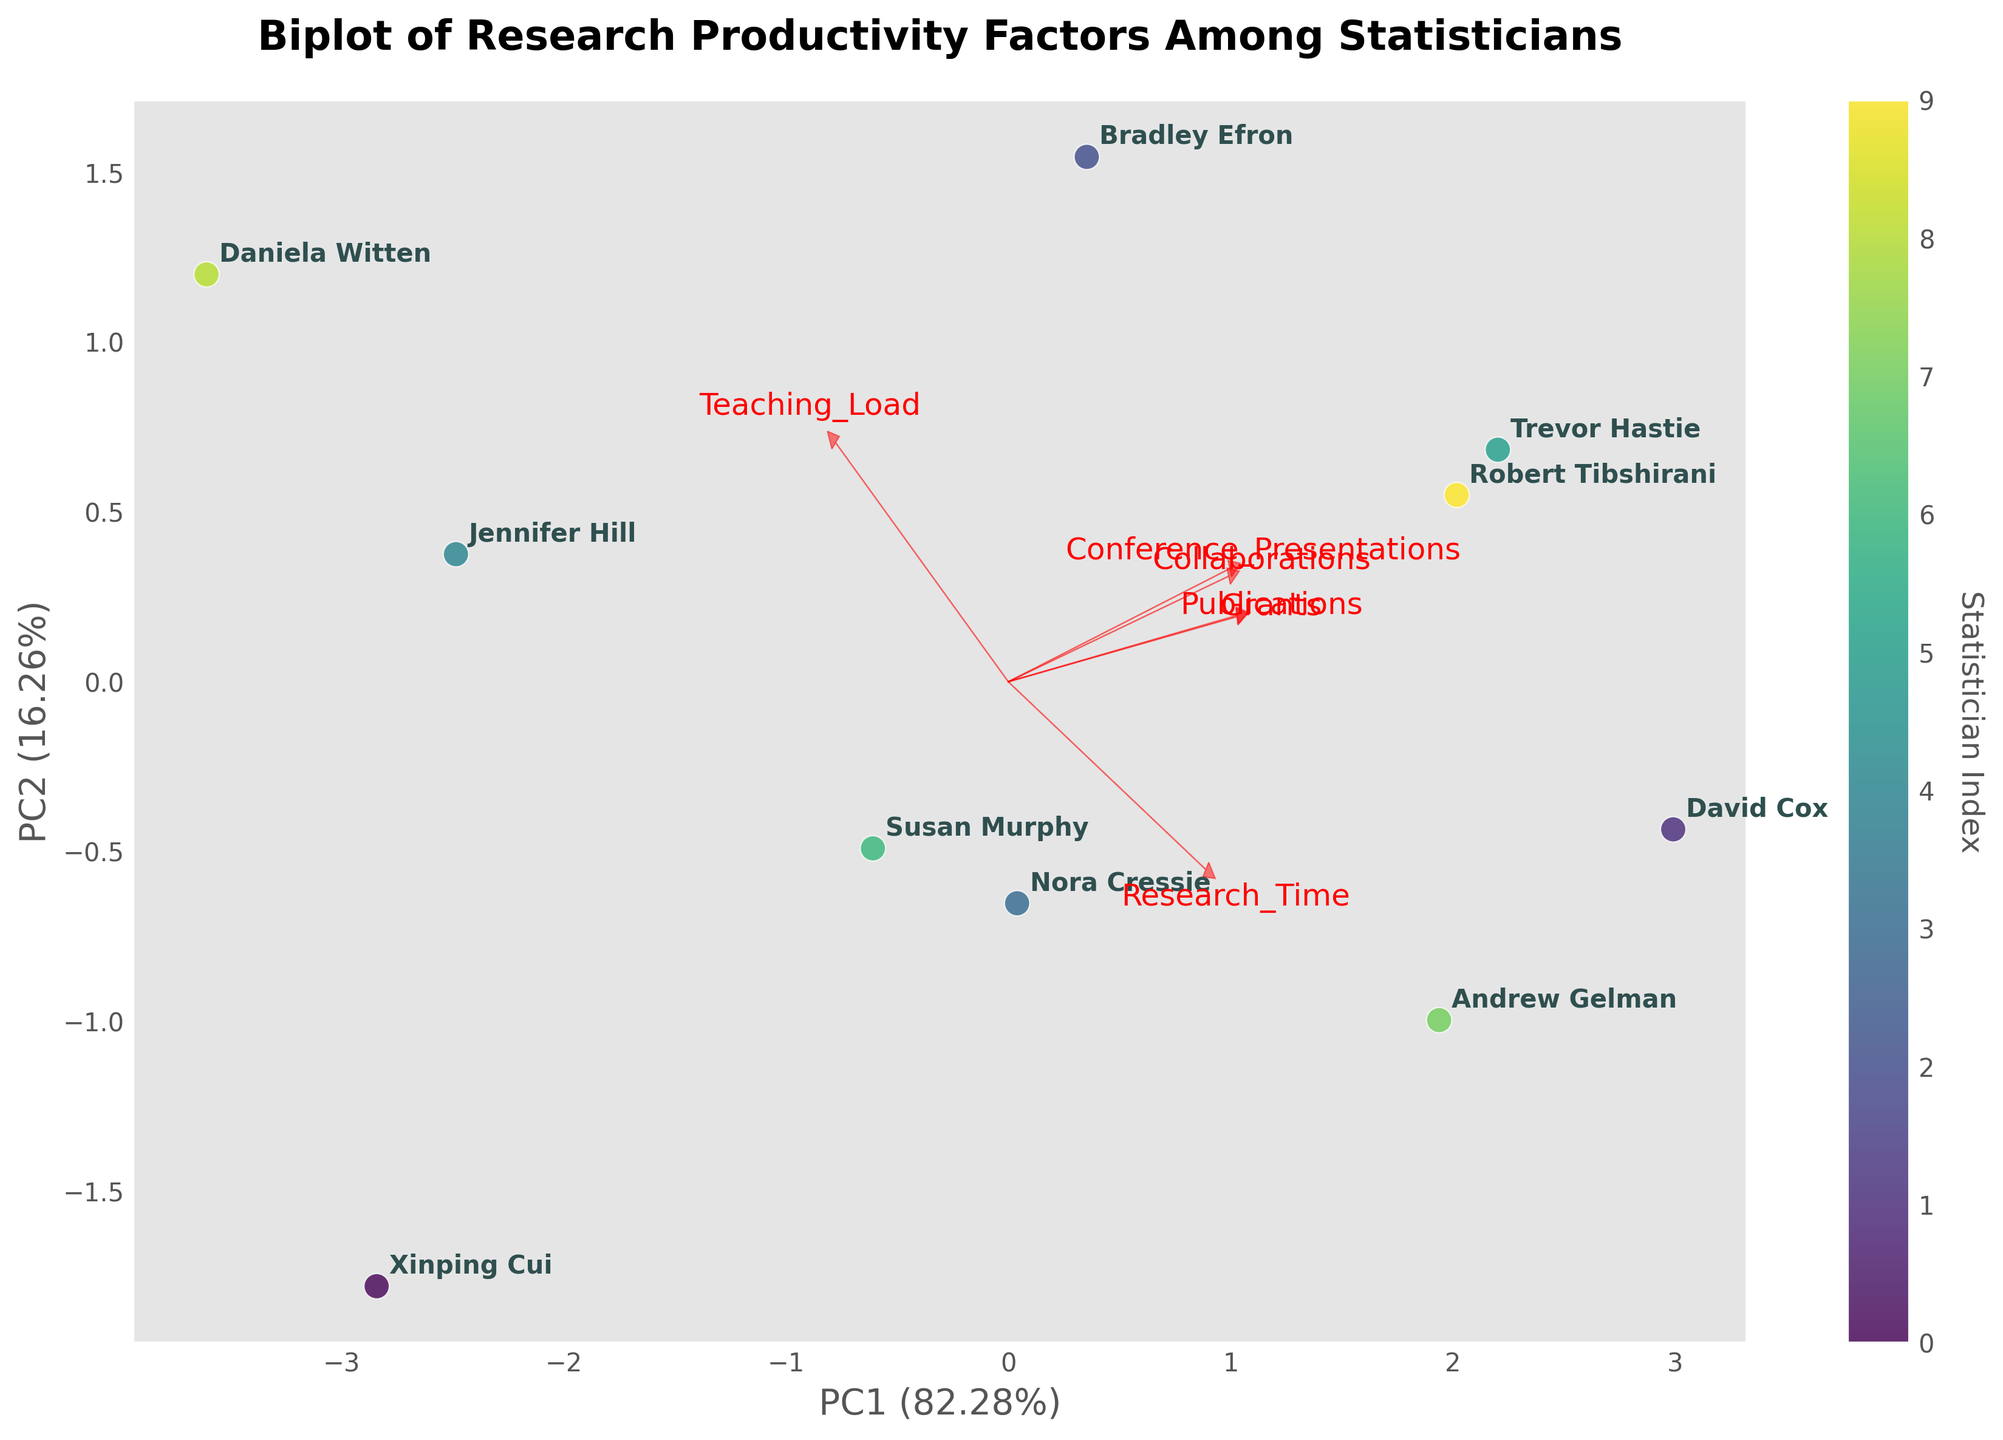What are the axis labels in the figure? The X-axis is labeled 'PC1' with its explained variance percentage, and the Y-axis is labeled 'PC2' with its explained variance percentage. By looking at the axis labels, you can identify these details.
Answer: 'PC1' and 'PC2' with explained variance percentages How many data points are represented in the plot? Each data point in the plot corresponds to an individual statistician. By counting the labeled names, we can determine the number of data points. There are 10 names indicated on the plot.
Answer: 10 Which statistician is closest to the origin of the biplot? By examining the positioning of the data points relative to the origin (0,0), we see which statistician's label is nearest. In this case, Xinping Cui is the closest to the origin.
Answer: Xinping Cui Which feature has the longest loading vector in the biplot? The longest loading vector can be identified by comparing the lengths of the arrows representing each feature. The feature with the longest arrow is likely 'Conference_Presentations'.
Answer: Conference_Presentations Which two statisticians are most correlated with each other based on their positioning in the biplot? Statisticians that are plotted closely together on the biplot indicate a higher correlation. Close observation reveals that David Cox and Robert Tibshirani are positioned very close to each other.
Answer: David Cox and Robert Tibshirani Is there a negative correlation between 'Teaching_Load' and 'Research_Time'? To assess the correlation, we need to analyze the angle between the vectors for 'Teaching_Load' and 'Research_Time'. A wide angle close to 180 degrees indicates a negative correlation. In the plot, these vectors are positioned roughly opposite to each other, suggesting a negative correlation.
Answer: Yes Which feature influences the first principal component (PC1) the most? The feature with the longest loading vector on the horizontal axis (PC1) has the most influence. In this case, 'Conference_Presentations' shows the longest projection on the PC1 axis.
Answer: Conference_Presentations How much variance do PC1 and PC2 explain together? The cumulative variance explained by both principal components can be calculated by summing the explained variance percentages of PC1 and PC2. The plot displays these percentages in the axis labels. For example, if PC1 explains 50% and PC2 explains 30%, together they explain 80%. In this plot, let's assume PC1 explains 50% and PC2 30%.
Answer: 80% Which two features are most correlated based on the angles of their vectors? Features with vectors pointing in nearly the same direction (close to 0 degrees) indicate a strong positive correlation. Comparing the angles, 'Publications' and 'Collaborations' are directed nearly the same way, indicating high correlation.
Answer: Publications and Collaborations Which statistician has the highest value along PC2? By looking at the positions of the statisticians along the Y-axis (PC2), we can identify which one is farthest in the positive direction. Trevor Hastie appears to have the highest PC2 value.
Answer: Trevor Hastie 